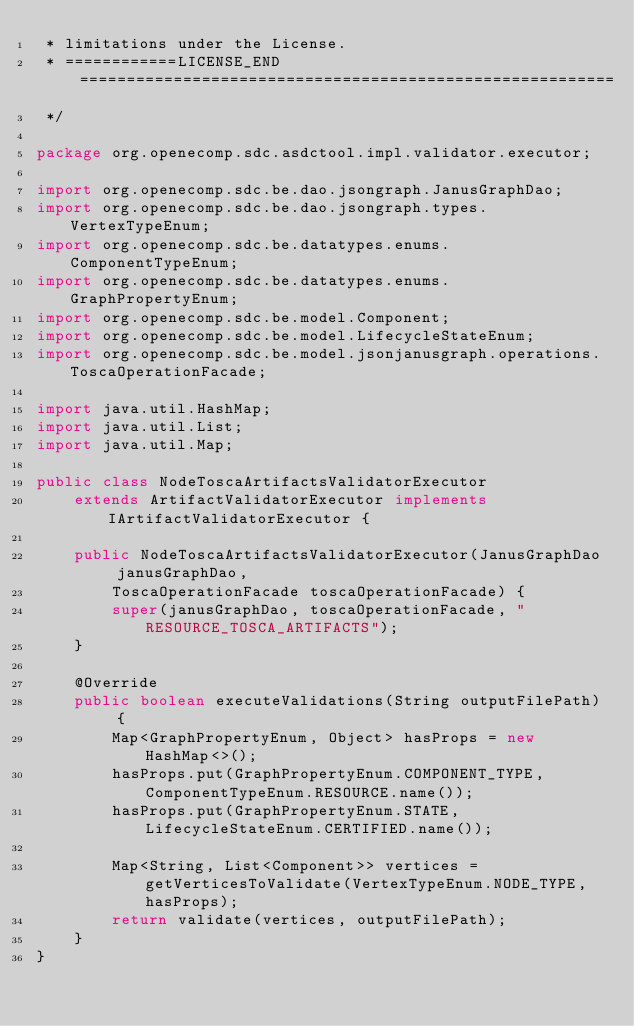Convert code to text. <code><loc_0><loc_0><loc_500><loc_500><_Java_> * limitations under the License.
 * ============LICENSE_END=========================================================
 */

package org.openecomp.sdc.asdctool.impl.validator.executor;

import org.openecomp.sdc.be.dao.jsongraph.JanusGraphDao;
import org.openecomp.sdc.be.dao.jsongraph.types.VertexTypeEnum;
import org.openecomp.sdc.be.datatypes.enums.ComponentTypeEnum;
import org.openecomp.sdc.be.datatypes.enums.GraphPropertyEnum;
import org.openecomp.sdc.be.model.Component;
import org.openecomp.sdc.be.model.LifecycleStateEnum;
import org.openecomp.sdc.be.model.jsonjanusgraph.operations.ToscaOperationFacade;

import java.util.HashMap;
import java.util.List;
import java.util.Map;

public class NodeToscaArtifactsValidatorExecutor
    extends ArtifactValidatorExecutor implements IArtifactValidatorExecutor {

    public NodeToscaArtifactsValidatorExecutor(JanusGraphDao janusGraphDao,
        ToscaOperationFacade toscaOperationFacade) {
        super(janusGraphDao, toscaOperationFacade, "RESOURCE_TOSCA_ARTIFACTS");
    }

    @Override
    public boolean executeValidations(String outputFilePath) {
        Map<GraphPropertyEnum, Object> hasProps = new HashMap<>();
        hasProps.put(GraphPropertyEnum.COMPONENT_TYPE, ComponentTypeEnum.RESOURCE.name());
        hasProps.put(GraphPropertyEnum.STATE, LifecycleStateEnum.CERTIFIED.name());

        Map<String, List<Component>> vertices = getVerticesToValidate(VertexTypeEnum.NODE_TYPE, hasProps);
        return validate(vertices, outputFilePath);
    }
}
</code> 